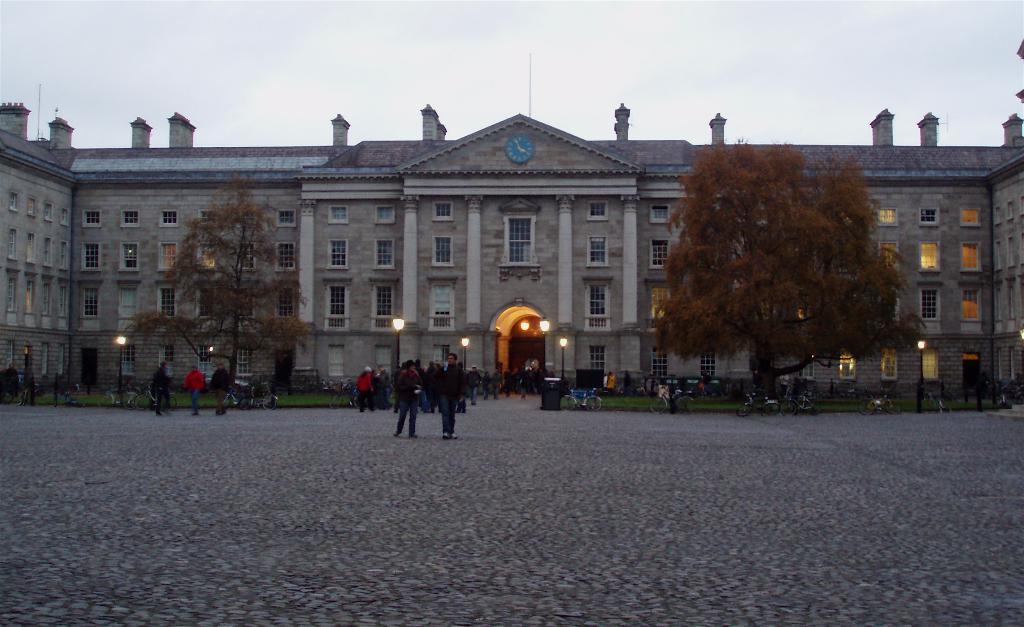Please provide a concise description of this image. In the center of the image we can see building, trees, wall, windows, lights, poles, some persons, bicycles, grass are there. At the top of the image sky, is there. At the bottom of the image ground is there. 